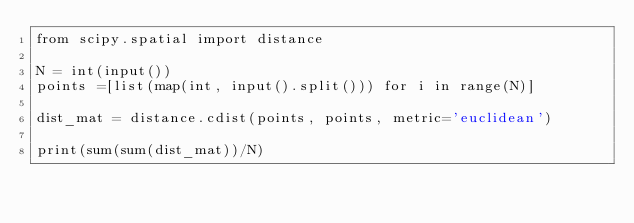<code> <loc_0><loc_0><loc_500><loc_500><_Python_>from scipy.spatial import distance

N = int(input())
points =[list(map(int, input().split())) for i in range(N)]

dist_mat = distance.cdist(points, points, metric='euclidean')

print(sum(sum(dist_mat))/N)</code> 